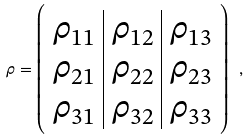Convert formula to latex. <formula><loc_0><loc_0><loc_500><loc_500>\rho = \left ( \begin{array} { c | c | c } \rho _ { 1 1 } & \rho _ { 1 2 } & \rho _ { 1 3 } \\ \rho _ { 2 1 } & \rho _ { 2 2 } & \rho _ { 2 3 } \\ \rho _ { 3 1 } & \rho _ { 3 2 } & \rho _ { 3 3 } \end{array} \right ) \ ,</formula> 